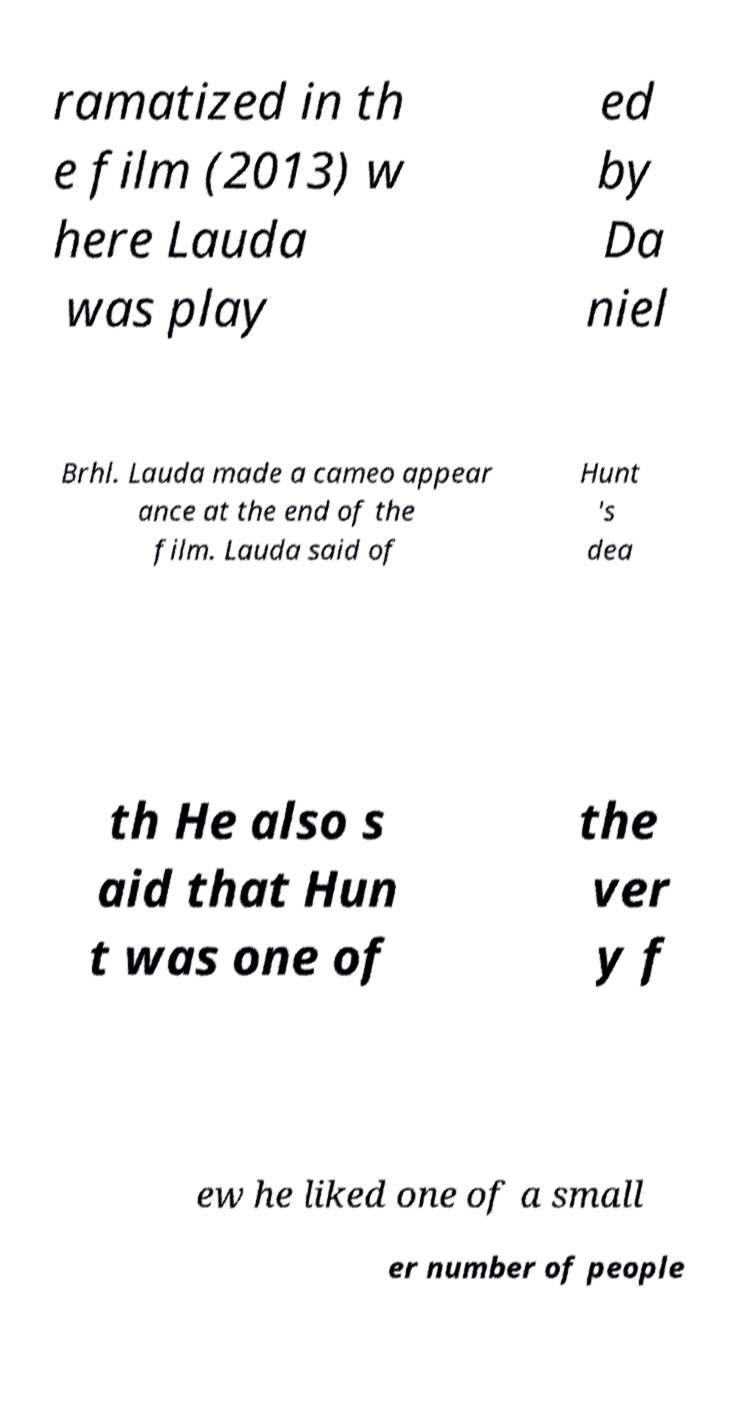Can you read and provide the text displayed in the image?This photo seems to have some interesting text. Can you extract and type it out for me? ramatized in th e film (2013) w here Lauda was play ed by Da niel Brhl. Lauda made a cameo appear ance at the end of the film. Lauda said of Hunt 's dea th He also s aid that Hun t was one of the ver y f ew he liked one of a small er number of people 